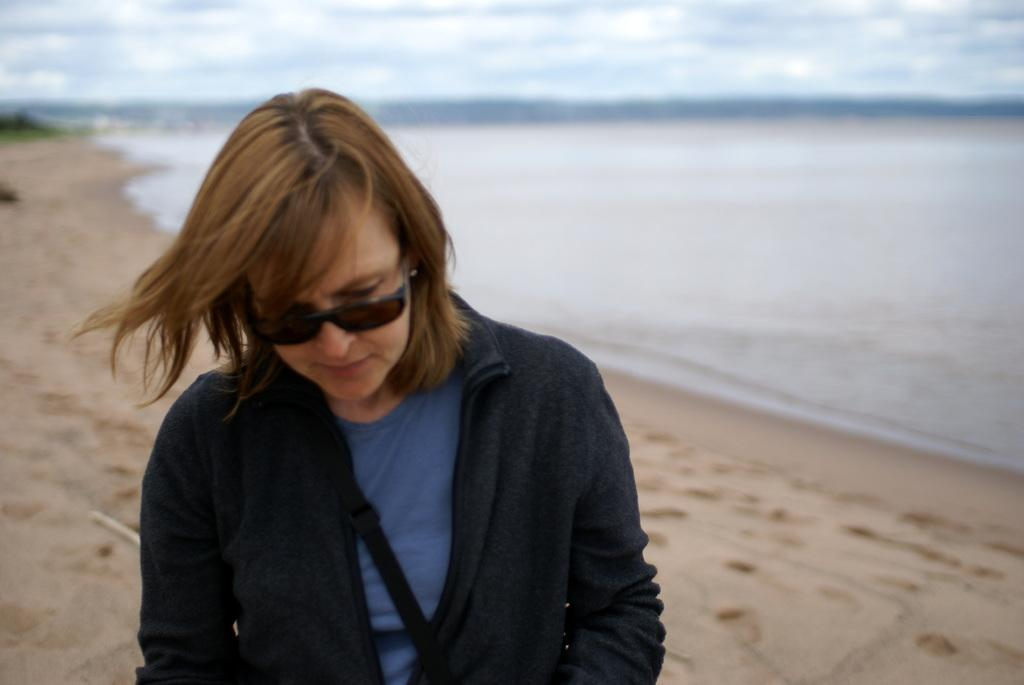Who is present in the image? There is a person in the image. What is the person wearing? The person is wearing clothes and sunglasses. What can be seen in the background of the image? There is a beach and sky visible in the background of the image. How many ladybugs are crawling on the person's clothes in the image? There are no ladybugs present in the image. What type of whip is being used by the person in the image? There is no whip present in the image. 